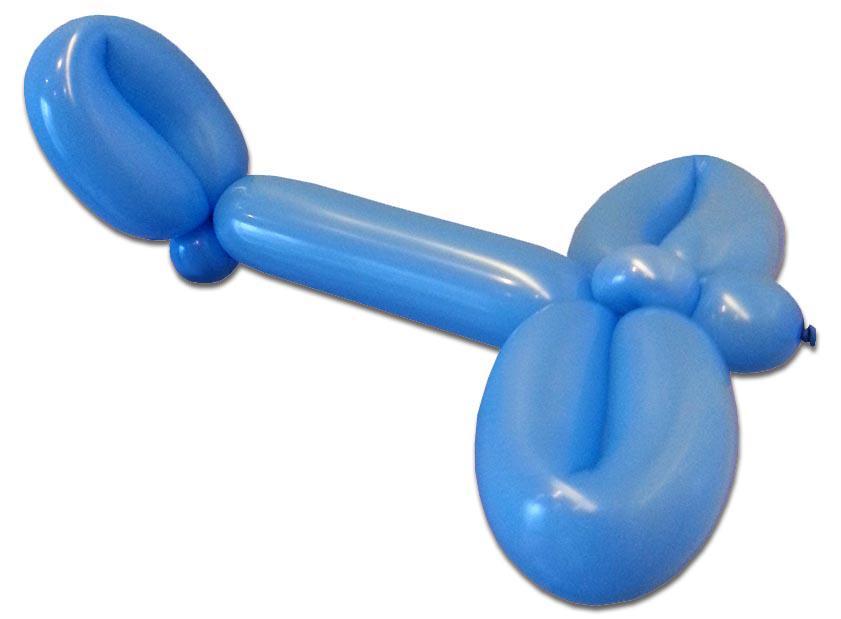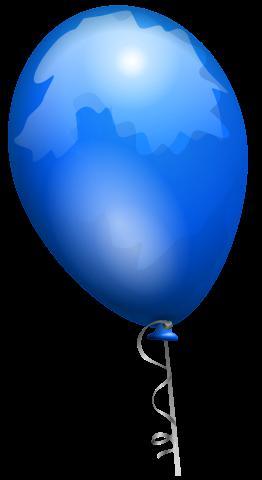The first image is the image on the left, the second image is the image on the right. For the images shown, is this caption "At least one balloon has a string attached." true? Answer yes or no. Yes. 